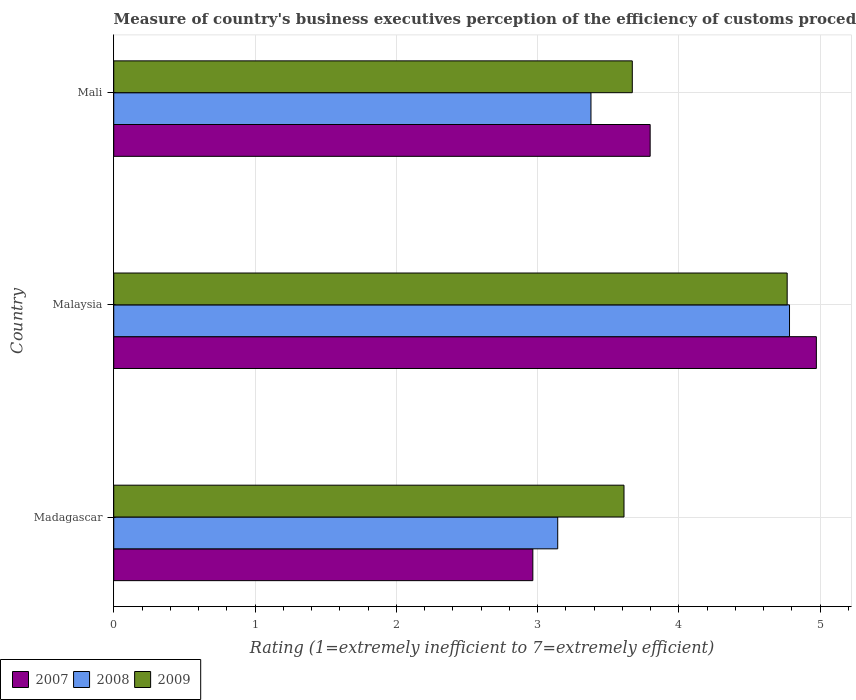How many different coloured bars are there?
Make the answer very short. 3. How many groups of bars are there?
Give a very brief answer. 3. Are the number of bars per tick equal to the number of legend labels?
Give a very brief answer. Yes. Are the number of bars on each tick of the Y-axis equal?
Make the answer very short. Yes. How many bars are there on the 2nd tick from the top?
Your response must be concise. 3. What is the label of the 1st group of bars from the top?
Provide a short and direct response. Mali. What is the rating of the efficiency of customs procedure in 2007 in Madagascar?
Your response must be concise. 2.97. Across all countries, what is the maximum rating of the efficiency of customs procedure in 2008?
Ensure brevity in your answer.  4.78. Across all countries, what is the minimum rating of the efficiency of customs procedure in 2009?
Provide a succinct answer. 3.61. In which country was the rating of the efficiency of customs procedure in 2009 maximum?
Give a very brief answer. Malaysia. In which country was the rating of the efficiency of customs procedure in 2009 minimum?
Your response must be concise. Madagascar. What is the total rating of the efficiency of customs procedure in 2008 in the graph?
Provide a succinct answer. 11.3. What is the difference between the rating of the efficiency of customs procedure in 2008 in Madagascar and that in Mali?
Keep it short and to the point. -0.24. What is the difference between the rating of the efficiency of customs procedure in 2008 in Malaysia and the rating of the efficiency of customs procedure in 2009 in Madagascar?
Your answer should be compact. 1.17. What is the average rating of the efficiency of customs procedure in 2009 per country?
Ensure brevity in your answer.  4.02. What is the difference between the rating of the efficiency of customs procedure in 2007 and rating of the efficiency of customs procedure in 2009 in Malaysia?
Your response must be concise. 0.21. In how many countries, is the rating of the efficiency of customs procedure in 2009 greater than 0.6000000000000001 ?
Give a very brief answer. 3. What is the ratio of the rating of the efficiency of customs procedure in 2009 in Madagascar to that in Malaysia?
Your answer should be compact. 0.76. What is the difference between the highest and the second highest rating of the efficiency of customs procedure in 2008?
Keep it short and to the point. 1.41. What is the difference between the highest and the lowest rating of the efficiency of customs procedure in 2007?
Give a very brief answer. 2.01. In how many countries, is the rating of the efficiency of customs procedure in 2008 greater than the average rating of the efficiency of customs procedure in 2008 taken over all countries?
Your response must be concise. 1. What does the 2nd bar from the bottom in Mali represents?
Your answer should be compact. 2008. How many bars are there?
Ensure brevity in your answer.  9. How many countries are there in the graph?
Offer a very short reply. 3. Are the values on the major ticks of X-axis written in scientific E-notation?
Make the answer very short. No. Does the graph contain any zero values?
Give a very brief answer. No. Where does the legend appear in the graph?
Give a very brief answer. Bottom left. How many legend labels are there?
Offer a terse response. 3. How are the legend labels stacked?
Offer a terse response. Horizontal. What is the title of the graph?
Keep it short and to the point. Measure of country's business executives perception of the efficiency of customs procedures. Does "1999" appear as one of the legend labels in the graph?
Provide a succinct answer. No. What is the label or title of the X-axis?
Ensure brevity in your answer.  Rating (1=extremely inefficient to 7=extremely efficient). What is the Rating (1=extremely inefficient to 7=extremely efficient) of 2007 in Madagascar?
Keep it short and to the point. 2.97. What is the Rating (1=extremely inefficient to 7=extremely efficient) of 2008 in Madagascar?
Offer a terse response. 3.14. What is the Rating (1=extremely inefficient to 7=extremely efficient) of 2009 in Madagascar?
Provide a succinct answer. 3.61. What is the Rating (1=extremely inefficient to 7=extremely efficient) of 2007 in Malaysia?
Your answer should be compact. 4.97. What is the Rating (1=extremely inefficient to 7=extremely efficient) of 2008 in Malaysia?
Offer a very short reply. 4.78. What is the Rating (1=extremely inefficient to 7=extremely efficient) in 2009 in Malaysia?
Your response must be concise. 4.77. What is the Rating (1=extremely inefficient to 7=extremely efficient) of 2007 in Mali?
Make the answer very short. 3.8. What is the Rating (1=extremely inefficient to 7=extremely efficient) in 2008 in Mali?
Offer a terse response. 3.38. What is the Rating (1=extremely inefficient to 7=extremely efficient) of 2009 in Mali?
Offer a terse response. 3.67. Across all countries, what is the maximum Rating (1=extremely inefficient to 7=extremely efficient) of 2007?
Your answer should be very brief. 4.97. Across all countries, what is the maximum Rating (1=extremely inefficient to 7=extremely efficient) of 2008?
Offer a very short reply. 4.78. Across all countries, what is the maximum Rating (1=extremely inefficient to 7=extremely efficient) of 2009?
Make the answer very short. 4.77. Across all countries, what is the minimum Rating (1=extremely inefficient to 7=extremely efficient) in 2007?
Offer a very short reply. 2.97. Across all countries, what is the minimum Rating (1=extremely inefficient to 7=extremely efficient) of 2008?
Offer a very short reply. 3.14. Across all countries, what is the minimum Rating (1=extremely inefficient to 7=extremely efficient) of 2009?
Ensure brevity in your answer.  3.61. What is the total Rating (1=extremely inefficient to 7=extremely efficient) in 2007 in the graph?
Your answer should be compact. 11.74. What is the total Rating (1=extremely inefficient to 7=extremely efficient) in 2008 in the graph?
Your answer should be very brief. 11.3. What is the total Rating (1=extremely inefficient to 7=extremely efficient) in 2009 in the graph?
Make the answer very short. 12.05. What is the difference between the Rating (1=extremely inefficient to 7=extremely efficient) of 2007 in Madagascar and that in Malaysia?
Your answer should be compact. -2.01. What is the difference between the Rating (1=extremely inefficient to 7=extremely efficient) in 2008 in Madagascar and that in Malaysia?
Offer a terse response. -1.64. What is the difference between the Rating (1=extremely inefficient to 7=extremely efficient) of 2009 in Madagascar and that in Malaysia?
Provide a succinct answer. -1.15. What is the difference between the Rating (1=extremely inefficient to 7=extremely efficient) in 2007 in Madagascar and that in Mali?
Give a very brief answer. -0.83. What is the difference between the Rating (1=extremely inefficient to 7=extremely efficient) of 2008 in Madagascar and that in Mali?
Offer a terse response. -0.24. What is the difference between the Rating (1=extremely inefficient to 7=extremely efficient) of 2009 in Madagascar and that in Mali?
Keep it short and to the point. -0.06. What is the difference between the Rating (1=extremely inefficient to 7=extremely efficient) of 2007 in Malaysia and that in Mali?
Offer a very short reply. 1.18. What is the difference between the Rating (1=extremely inefficient to 7=extremely efficient) in 2008 in Malaysia and that in Mali?
Your answer should be very brief. 1.41. What is the difference between the Rating (1=extremely inefficient to 7=extremely efficient) in 2009 in Malaysia and that in Mali?
Provide a short and direct response. 1.1. What is the difference between the Rating (1=extremely inefficient to 7=extremely efficient) of 2007 in Madagascar and the Rating (1=extremely inefficient to 7=extremely efficient) of 2008 in Malaysia?
Your answer should be very brief. -1.82. What is the difference between the Rating (1=extremely inefficient to 7=extremely efficient) in 2007 in Madagascar and the Rating (1=extremely inefficient to 7=extremely efficient) in 2009 in Malaysia?
Provide a short and direct response. -1.8. What is the difference between the Rating (1=extremely inefficient to 7=extremely efficient) in 2008 in Madagascar and the Rating (1=extremely inefficient to 7=extremely efficient) in 2009 in Malaysia?
Your answer should be very brief. -1.62. What is the difference between the Rating (1=extremely inefficient to 7=extremely efficient) of 2007 in Madagascar and the Rating (1=extremely inefficient to 7=extremely efficient) of 2008 in Mali?
Ensure brevity in your answer.  -0.41. What is the difference between the Rating (1=extremely inefficient to 7=extremely efficient) in 2007 in Madagascar and the Rating (1=extremely inefficient to 7=extremely efficient) in 2009 in Mali?
Keep it short and to the point. -0.7. What is the difference between the Rating (1=extremely inefficient to 7=extremely efficient) in 2008 in Madagascar and the Rating (1=extremely inefficient to 7=extremely efficient) in 2009 in Mali?
Provide a succinct answer. -0.53. What is the difference between the Rating (1=extremely inefficient to 7=extremely efficient) of 2007 in Malaysia and the Rating (1=extremely inefficient to 7=extremely efficient) of 2008 in Mali?
Offer a terse response. 1.6. What is the difference between the Rating (1=extremely inefficient to 7=extremely efficient) in 2007 in Malaysia and the Rating (1=extremely inefficient to 7=extremely efficient) in 2009 in Mali?
Make the answer very short. 1.3. What is the difference between the Rating (1=extremely inefficient to 7=extremely efficient) in 2008 in Malaysia and the Rating (1=extremely inefficient to 7=extremely efficient) in 2009 in Mali?
Offer a terse response. 1.11. What is the average Rating (1=extremely inefficient to 7=extremely efficient) in 2007 per country?
Your answer should be very brief. 3.91. What is the average Rating (1=extremely inefficient to 7=extremely efficient) of 2008 per country?
Give a very brief answer. 3.77. What is the average Rating (1=extremely inefficient to 7=extremely efficient) of 2009 per country?
Provide a short and direct response. 4.02. What is the difference between the Rating (1=extremely inefficient to 7=extremely efficient) in 2007 and Rating (1=extremely inefficient to 7=extremely efficient) in 2008 in Madagascar?
Give a very brief answer. -0.18. What is the difference between the Rating (1=extremely inefficient to 7=extremely efficient) in 2007 and Rating (1=extremely inefficient to 7=extremely efficient) in 2009 in Madagascar?
Your answer should be compact. -0.65. What is the difference between the Rating (1=extremely inefficient to 7=extremely efficient) of 2008 and Rating (1=extremely inefficient to 7=extremely efficient) of 2009 in Madagascar?
Offer a terse response. -0.47. What is the difference between the Rating (1=extremely inefficient to 7=extremely efficient) in 2007 and Rating (1=extremely inefficient to 7=extremely efficient) in 2008 in Malaysia?
Offer a very short reply. 0.19. What is the difference between the Rating (1=extremely inefficient to 7=extremely efficient) of 2007 and Rating (1=extremely inefficient to 7=extremely efficient) of 2009 in Malaysia?
Keep it short and to the point. 0.21. What is the difference between the Rating (1=extremely inefficient to 7=extremely efficient) in 2008 and Rating (1=extremely inefficient to 7=extremely efficient) in 2009 in Malaysia?
Your answer should be compact. 0.02. What is the difference between the Rating (1=extremely inefficient to 7=extremely efficient) of 2007 and Rating (1=extremely inefficient to 7=extremely efficient) of 2008 in Mali?
Make the answer very short. 0.42. What is the difference between the Rating (1=extremely inefficient to 7=extremely efficient) of 2007 and Rating (1=extremely inefficient to 7=extremely efficient) of 2009 in Mali?
Your answer should be compact. 0.13. What is the difference between the Rating (1=extremely inefficient to 7=extremely efficient) in 2008 and Rating (1=extremely inefficient to 7=extremely efficient) in 2009 in Mali?
Your answer should be very brief. -0.29. What is the ratio of the Rating (1=extremely inefficient to 7=extremely efficient) of 2007 in Madagascar to that in Malaysia?
Your answer should be compact. 0.6. What is the ratio of the Rating (1=extremely inefficient to 7=extremely efficient) of 2008 in Madagascar to that in Malaysia?
Make the answer very short. 0.66. What is the ratio of the Rating (1=extremely inefficient to 7=extremely efficient) of 2009 in Madagascar to that in Malaysia?
Keep it short and to the point. 0.76. What is the ratio of the Rating (1=extremely inefficient to 7=extremely efficient) in 2007 in Madagascar to that in Mali?
Your answer should be very brief. 0.78. What is the ratio of the Rating (1=extremely inefficient to 7=extremely efficient) of 2008 in Madagascar to that in Mali?
Keep it short and to the point. 0.93. What is the ratio of the Rating (1=extremely inefficient to 7=extremely efficient) in 2007 in Malaysia to that in Mali?
Keep it short and to the point. 1.31. What is the ratio of the Rating (1=extremely inefficient to 7=extremely efficient) in 2008 in Malaysia to that in Mali?
Make the answer very short. 1.42. What is the ratio of the Rating (1=extremely inefficient to 7=extremely efficient) in 2009 in Malaysia to that in Mali?
Give a very brief answer. 1.3. What is the difference between the highest and the second highest Rating (1=extremely inefficient to 7=extremely efficient) of 2007?
Offer a terse response. 1.18. What is the difference between the highest and the second highest Rating (1=extremely inefficient to 7=extremely efficient) in 2008?
Give a very brief answer. 1.41. What is the difference between the highest and the second highest Rating (1=extremely inefficient to 7=extremely efficient) of 2009?
Your answer should be very brief. 1.1. What is the difference between the highest and the lowest Rating (1=extremely inefficient to 7=extremely efficient) in 2007?
Give a very brief answer. 2.01. What is the difference between the highest and the lowest Rating (1=extremely inefficient to 7=extremely efficient) in 2008?
Give a very brief answer. 1.64. What is the difference between the highest and the lowest Rating (1=extremely inefficient to 7=extremely efficient) of 2009?
Provide a short and direct response. 1.15. 